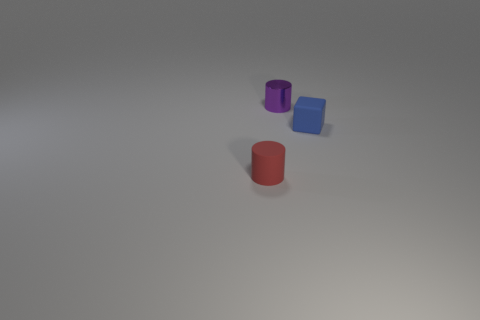Add 1 rubber objects. How many objects exist? 4 Subtract all cylinders. How many objects are left? 1 Add 1 matte cylinders. How many matte cylinders are left? 2 Add 2 small blue rubber things. How many small blue rubber things exist? 3 Subtract 1 blue cubes. How many objects are left? 2 Subtract all blue matte blocks. Subtract all small blue matte spheres. How many objects are left? 2 